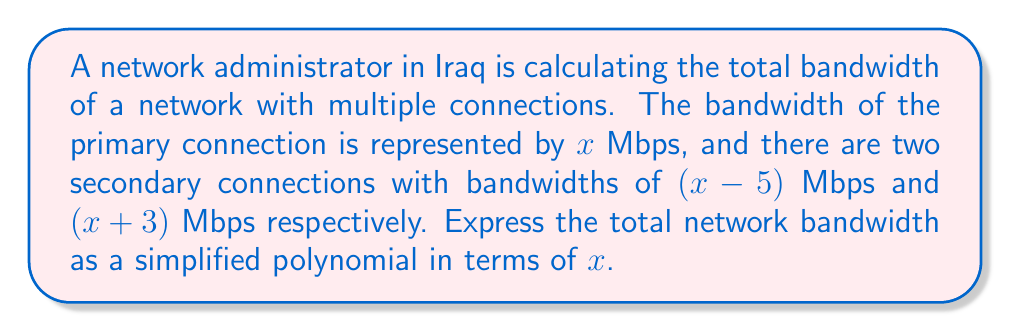Show me your answer to this math problem. Let's approach this step-by-step:

1) The total bandwidth is the sum of all connections:
   $$ \text{Total Bandwidth} = x + (x-5) + (x+3) $$

2) Let's expand this expression:
   $$ \text{Total Bandwidth} = x + x - 5 + x + 3 $$

3) Now, we can combine like terms:
   $$ \text{Total Bandwidth} = x + x + x - 5 + 3 $$
   $$ \text{Total Bandwidth} = 3x - 2 $$

4) This polynomial is already in its simplest form, as we cannot factor it further.

Therefore, the total network bandwidth, expressed as a simplified polynomial in terms of $x$, is $3x - 2$ Mbps.
Answer: $3x - 2$ Mbps 